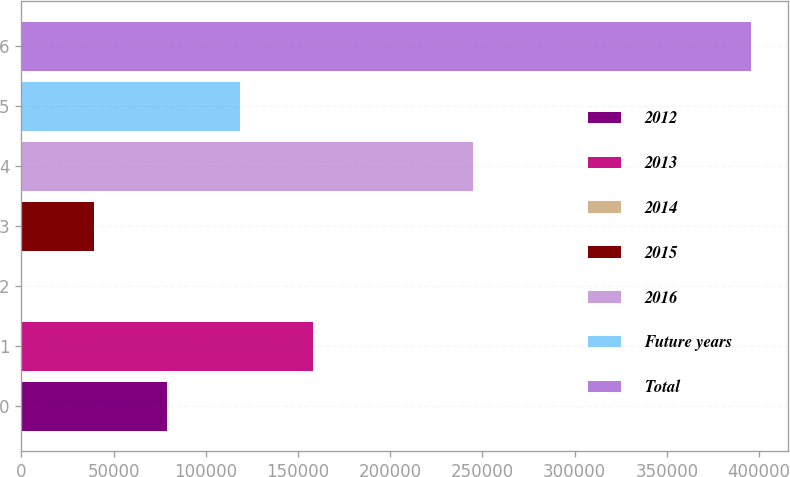Convert chart to OTSL. <chart><loc_0><loc_0><loc_500><loc_500><bar_chart><fcel>2012<fcel>2013<fcel>2014<fcel>2015<fcel>2016<fcel>Future years<fcel>Total<nl><fcel>79198.6<fcel>158367<fcel>30<fcel>39614.3<fcel>245030<fcel>118783<fcel>395873<nl></chart> 